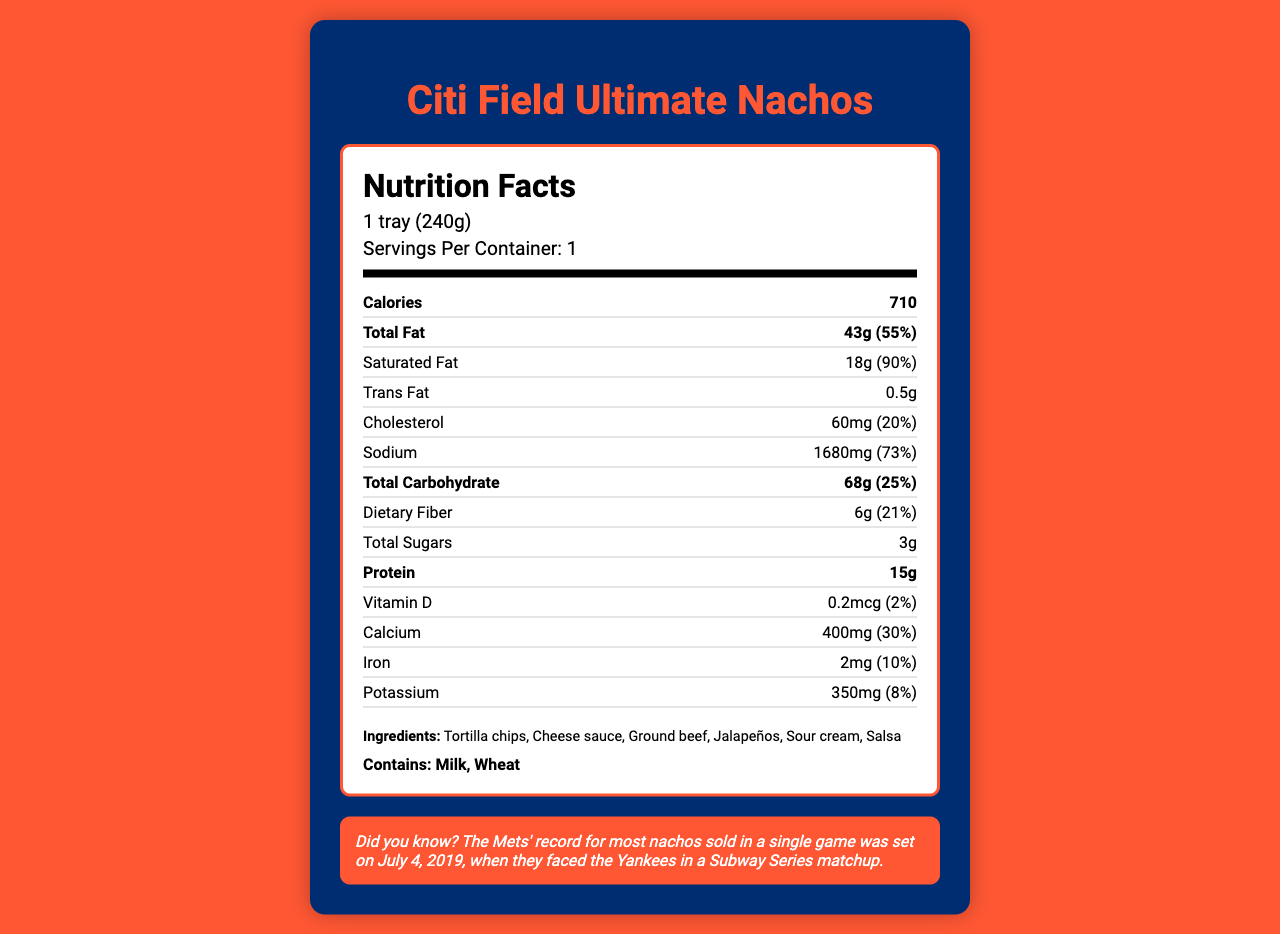what is the serving size? The serving size is explicitly listed in the document as "1 tray (240g)".
Answer: 1 tray (240g) how many grams of total fat are in a serving? The total fat content per serving is mentioned as 43 grams in the document.
Answer: 43g what percentage of the daily value is the saturated fat? The percentage daily value of saturated fat is shown as 90%.
Answer: 90% what is the amount of trans fat per serving? The document states that the amount of trans fat per serving is 0.5 grams.
Answer: 0.5g how many servings are in a container? The document indicates that there is 1 serving per container.
Answer: 1 what is the calorie content per serving? The nutrition facts label shows that each serving contains 710 calories.
Answer: 710 how much cholesterol is in a serving of these nachos? The document specifies that there are 60 milligrams of cholesterol per serving.
Answer: 60mg how much protein does a serving contain? The document shows that one serving contains 15 grams of protein.
Answer: 15g What is the main highlighted message in the document? The document is primarily highlighting the nutritional information for Citi Field Ultimate Nachos, detailing aspects such as fat content, calorie count, and other nutritional values, along with a fun fact related to the Mets.
Answer: The nutrition facts for Citi Field Ultimate Nachos, including detailed fat content and serving size, along with a fun fact about the Mets. The Citi Field Ultimate Nachos contain which allergens? A. Milk and Soy B. Soy and Wheat C. Milk and Wheat D. Peanut and Soy The document lists the allergens in the nachos as "Milk" and "Wheat".
Answer: C How many calories are derived from fat, if 1g of fat equals 9 calories? A. 387 B. 500 C. 3870 D. 710 Since 1 gram of fat equals 9 calories, 43 grams of fat equals 387 calories (43 * 9 = 387).
Answer: A Are the nachos suitable for someone managing their sodium intake? The document shows that the sodium content per serving is 1680mg, which is 73% of the daily value, indicating a high level of sodium.
Answer: No Is the information about vitamin C content available? The document does not provide any information regarding vitamin C content. Thus, it cannot be determined based on the available visual information.
Answer: Not enough information How much calcium is present in a serving? The document shows the calcium content as 400 milligrams per serving, which is 30% of the daily value.
Answer: 400mg 